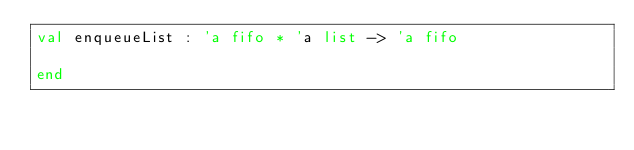<code> <loc_0><loc_0><loc_500><loc_500><_SML_>val enqueueList : 'a fifo * 'a list -> 'a fifo

end
</code> 